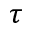<formula> <loc_0><loc_0><loc_500><loc_500>\tau</formula> 